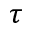<formula> <loc_0><loc_0><loc_500><loc_500>\tau</formula> 